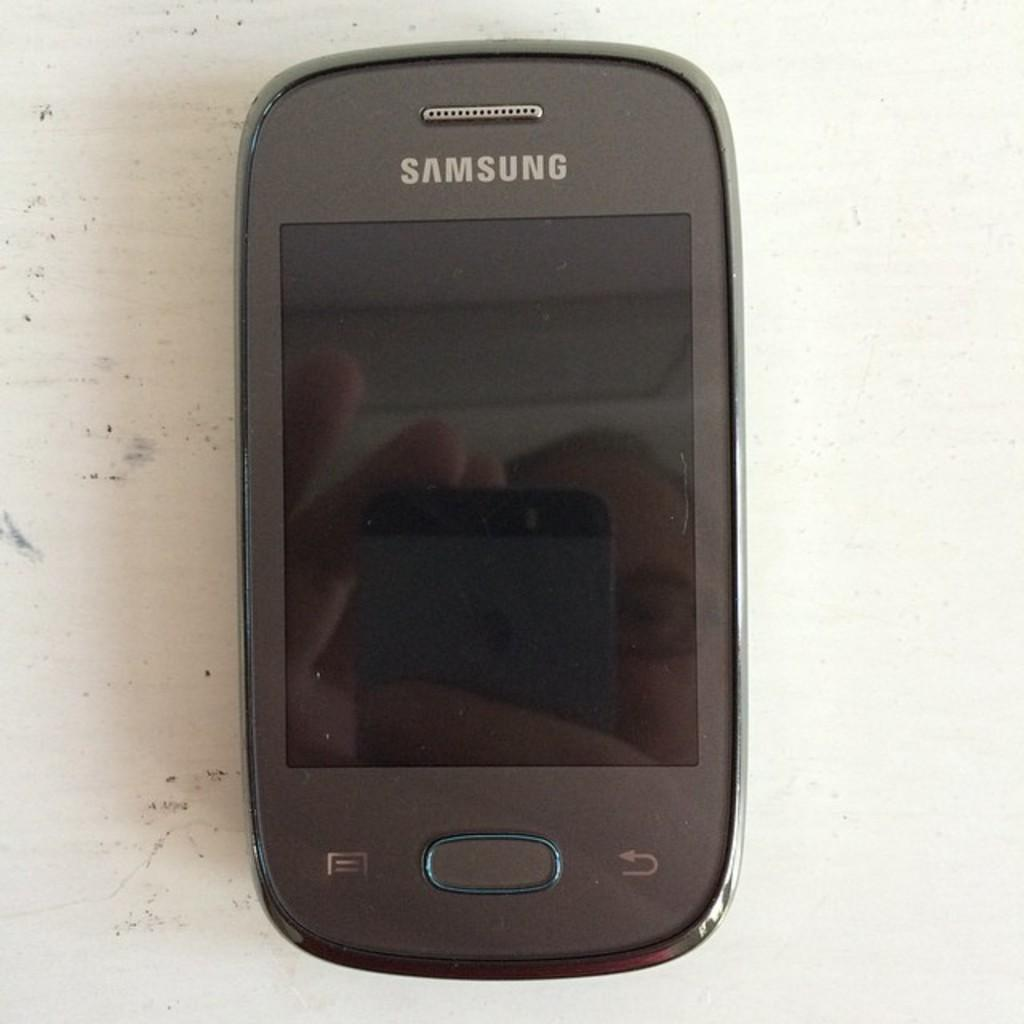Provide a one-sentence caption for the provided image. an old samsung cellular device sits powered off on a table. 